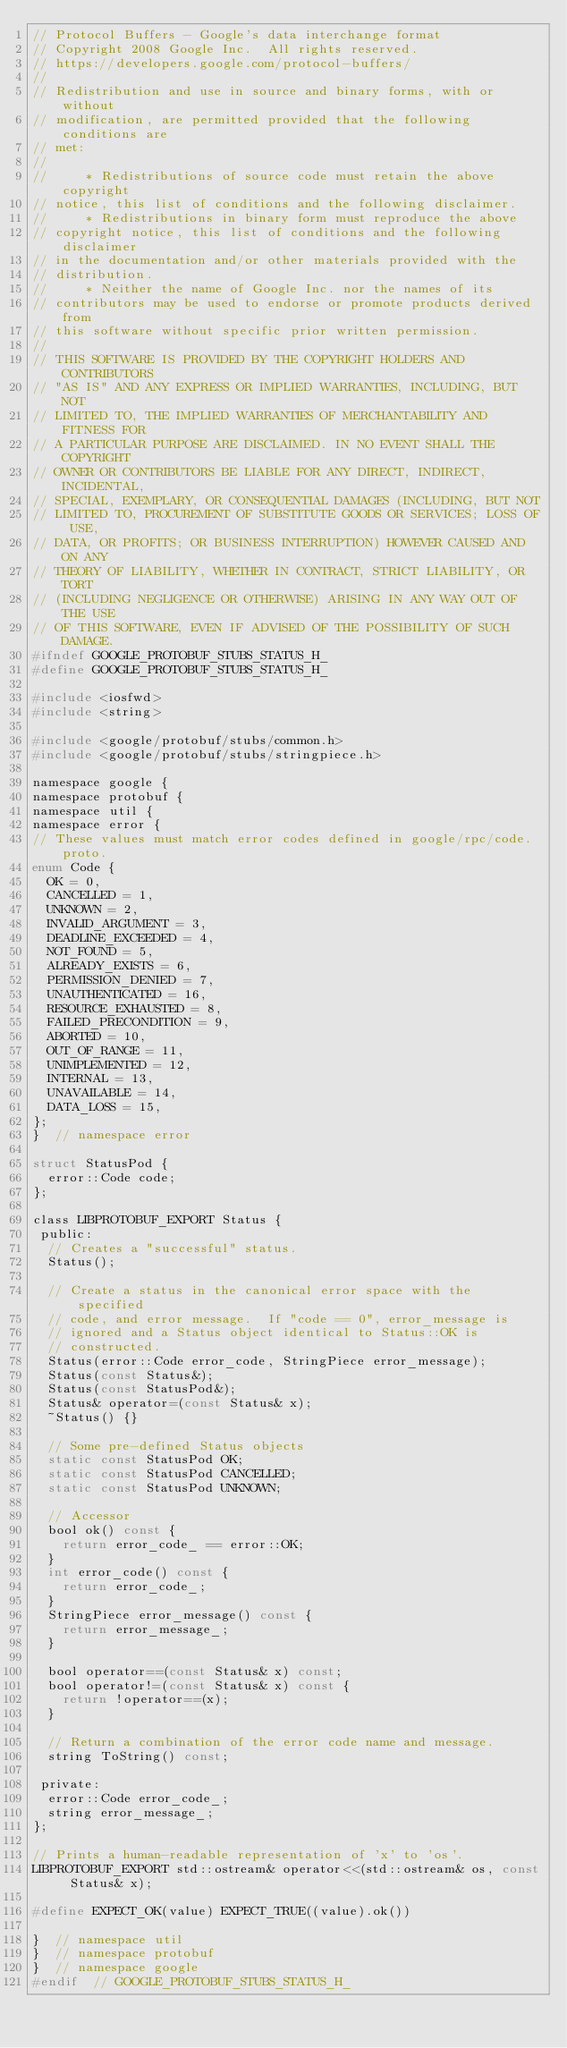<code> <loc_0><loc_0><loc_500><loc_500><_C_>// Protocol Buffers - Google's data interchange format
// Copyright 2008 Google Inc.  All rights reserved.
// https://developers.google.com/protocol-buffers/
//
// Redistribution and use in source and binary forms, with or without
// modification, are permitted provided that the following conditions are
// met:
//
//     * Redistributions of source code must retain the above copyright
// notice, this list of conditions and the following disclaimer.
//     * Redistributions in binary form must reproduce the above
// copyright notice, this list of conditions and the following disclaimer
// in the documentation and/or other materials provided with the
// distribution.
//     * Neither the name of Google Inc. nor the names of its
// contributors may be used to endorse or promote products derived from
// this software without specific prior written permission.
//
// THIS SOFTWARE IS PROVIDED BY THE COPYRIGHT HOLDERS AND CONTRIBUTORS
// "AS IS" AND ANY EXPRESS OR IMPLIED WARRANTIES, INCLUDING, BUT NOT
// LIMITED TO, THE IMPLIED WARRANTIES OF MERCHANTABILITY AND FITNESS FOR
// A PARTICULAR PURPOSE ARE DISCLAIMED. IN NO EVENT SHALL THE COPYRIGHT
// OWNER OR CONTRIBUTORS BE LIABLE FOR ANY DIRECT, INDIRECT, INCIDENTAL,
// SPECIAL, EXEMPLARY, OR CONSEQUENTIAL DAMAGES (INCLUDING, BUT NOT
// LIMITED TO, PROCUREMENT OF SUBSTITUTE GOODS OR SERVICES; LOSS OF USE,
// DATA, OR PROFITS; OR BUSINESS INTERRUPTION) HOWEVER CAUSED AND ON ANY
// THEORY OF LIABILITY, WHETHER IN CONTRACT, STRICT LIABILITY, OR TORT
// (INCLUDING NEGLIGENCE OR OTHERWISE) ARISING IN ANY WAY OUT OF THE USE
// OF THIS SOFTWARE, EVEN IF ADVISED OF THE POSSIBILITY OF SUCH DAMAGE.
#ifndef GOOGLE_PROTOBUF_STUBS_STATUS_H_
#define GOOGLE_PROTOBUF_STUBS_STATUS_H_

#include <iosfwd>
#include <string>

#include <google/protobuf/stubs/common.h>
#include <google/protobuf/stubs/stringpiece.h>

namespace google {
namespace protobuf {
namespace util {
namespace error {
// These values must match error codes defined in google/rpc/code.proto.
enum Code {
  OK = 0,
  CANCELLED = 1,
  UNKNOWN = 2,
  INVALID_ARGUMENT = 3,
  DEADLINE_EXCEEDED = 4,
  NOT_FOUND = 5,
  ALREADY_EXISTS = 6,
  PERMISSION_DENIED = 7,
  UNAUTHENTICATED = 16,
  RESOURCE_EXHAUSTED = 8,
  FAILED_PRECONDITION = 9,
  ABORTED = 10,
  OUT_OF_RANGE = 11,
  UNIMPLEMENTED = 12,
  INTERNAL = 13,
  UNAVAILABLE = 14,
  DATA_LOSS = 15,
};
}  // namespace error

struct StatusPod {
  error::Code code;
};

class LIBPROTOBUF_EXPORT Status {
 public:
  // Creates a "successful" status.
  Status();

  // Create a status in the canonical error space with the specified
  // code, and error message.  If "code == 0", error_message is
  // ignored and a Status object identical to Status::OK is
  // constructed.
  Status(error::Code error_code, StringPiece error_message);
  Status(const Status&);
  Status(const StatusPod&);
  Status& operator=(const Status& x);
  ~Status() {}

  // Some pre-defined Status objects
  static const StatusPod OK;
  static const StatusPod CANCELLED;
  static const StatusPod UNKNOWN;

  // Accessor
  bool ok() const {
    return error_code_ == error::OK;
  }
  int error_code() const {
    return error_code_;
  }
  StringPiece error_message() const {
    return error_message_;
  }

  bool operator==(const Status& x) const;
  bool operator!=(const Status& x) const {
    return !operator==(x);
  }

  // Return a combination of the error code name and message.
  string ToString() const;

 private:
  error::Code error_code_;
  string error_message_;
};

// Prints a human-readable representation of 'x' to 'os'.
LIBPROTOBUF_EXPORT std::ostream& operator<<(std::ostream& os, const Status& x);

#define EXPECT_OK(value) EXPECT_TRUE((value).ok())

}  // namespace util
}  // namespace protobuf
}  // namespace google
#endif  // GOOGLE_PROTOBUF_STUBS_STATUS_H_
</code> 